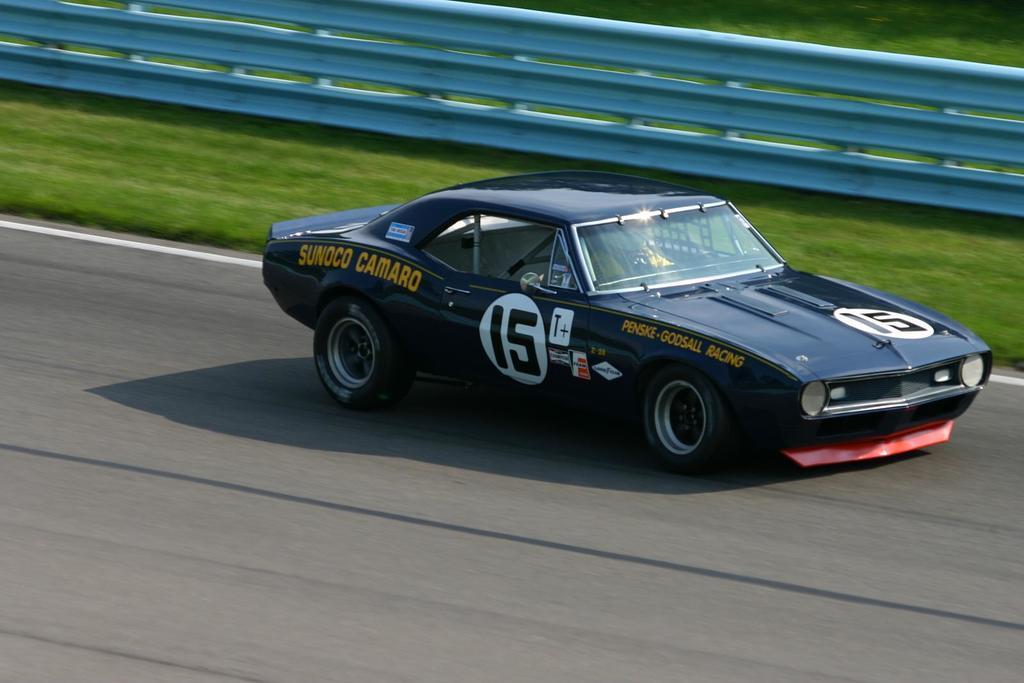Could you give a brief overview of what you see in this image? There is a car on the road. This is grass and there is a fence. 